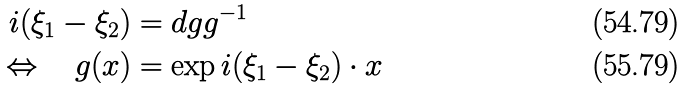<formula> <loc_0><loc_0><loc_500><loc_500>i ( \xi _ { 1 } - \xi _ { 2 } ) & = d g g ^ { - 1 } \\ \Leftrightarrow \quad g ( x ) & = \exp i ( \xi _ { 1 } - \xi _ { 2 } ) \cdot x</formula> 